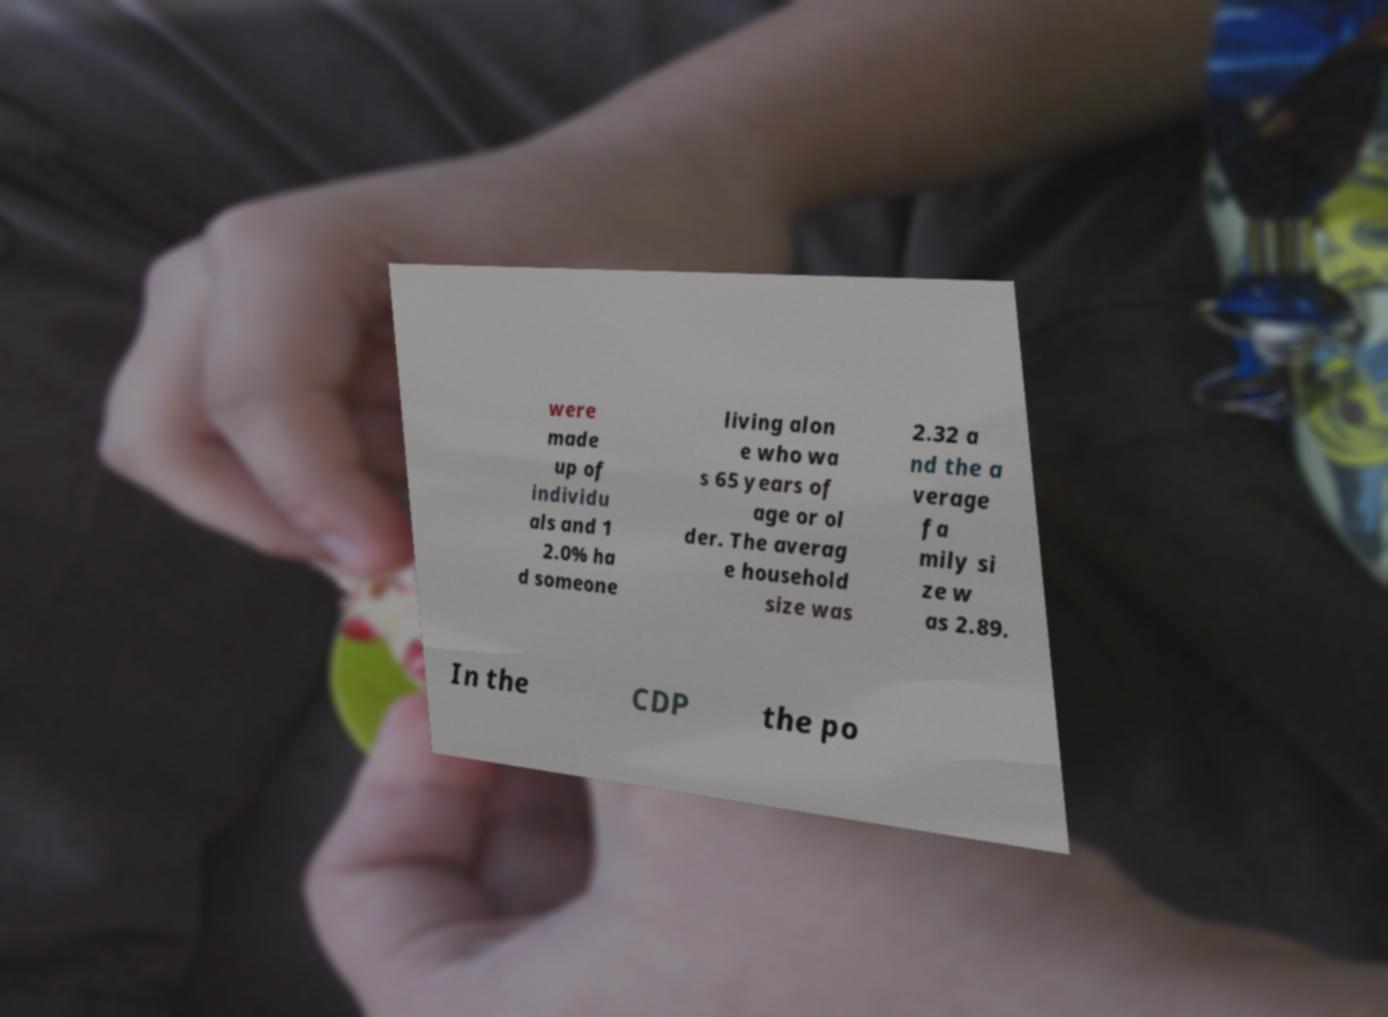Can you read and provide the text displayed in the image?This photo seems to have some interesting text. Can you extract and type it out for me? were made up of individu als and 1 2.0% ha d someone living alon e who wa s 65 years of age or ol der. The averag e household size was 2.32 a nd the a verage fa mily si ze w as 2.89. In the CDP the po 